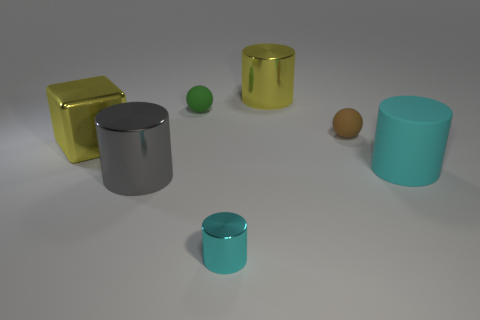Could you estimate the sizes of these objects? Although it's challenging to determine the precise sizes without a reference, we can infer relative sizes. The objects seem to range from small - such as the small green ball which could fit comfortably in one's hand - to larger objects like the blue and gray cylinders, which could be the size of containers or vases. The golden block appears to be the largest and might be similar in size to a small household appliance or a large book. 